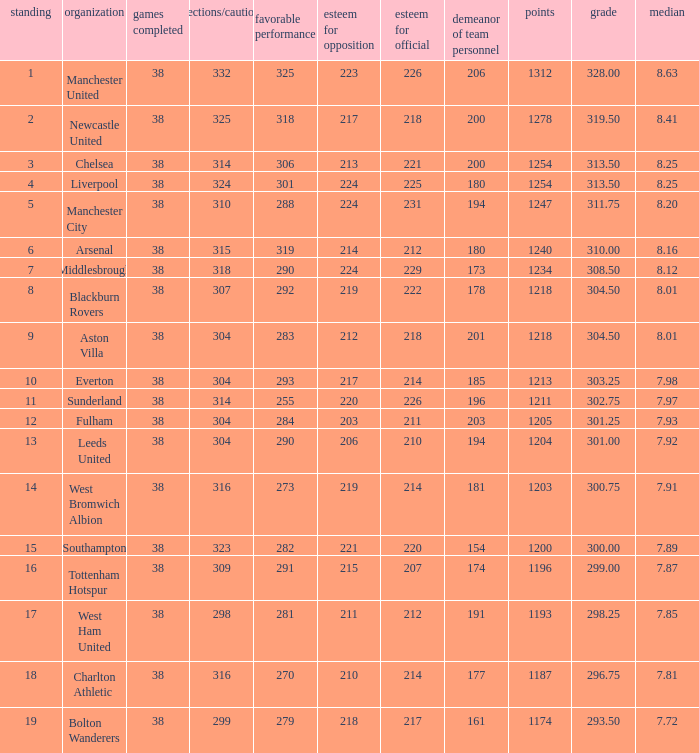Name the most pos for west bromwich albion club 14.0. 